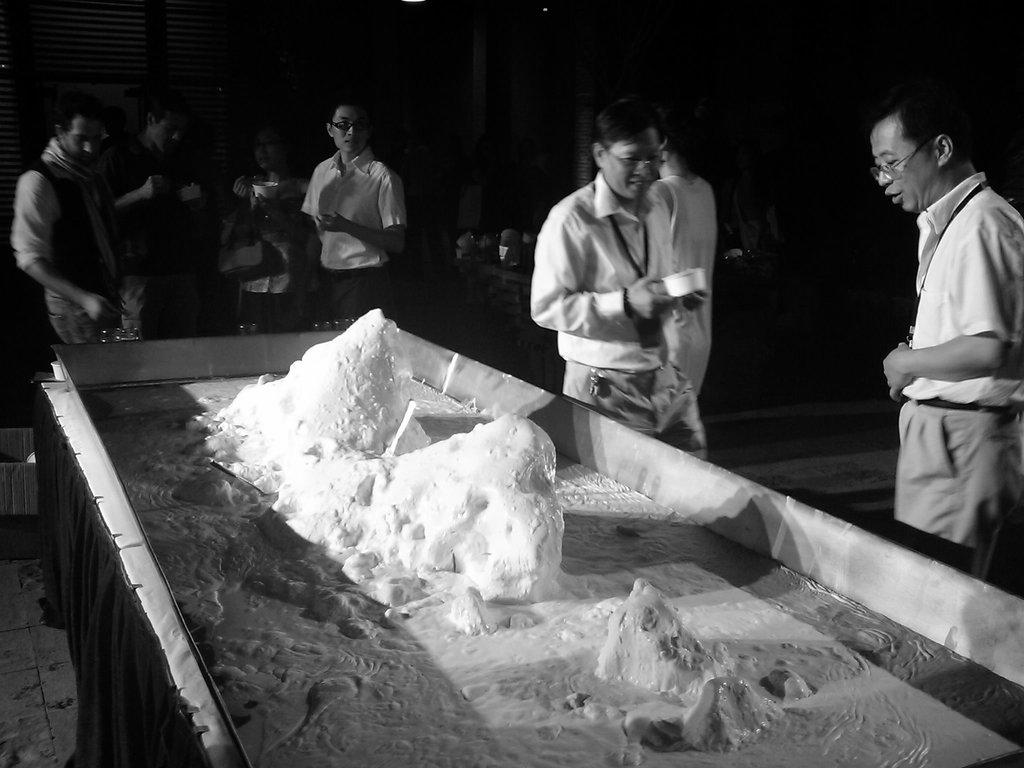What is happening in the image? There are people standing in the image. What is the surface that the people are standing on? The people are standing on a surface. Can you describe the object on the table in the image? Unfortunately, the facts provided do not mention any object on a table in the image. How many pies are on the hill in the image? There is no hill or pies present in the image. 